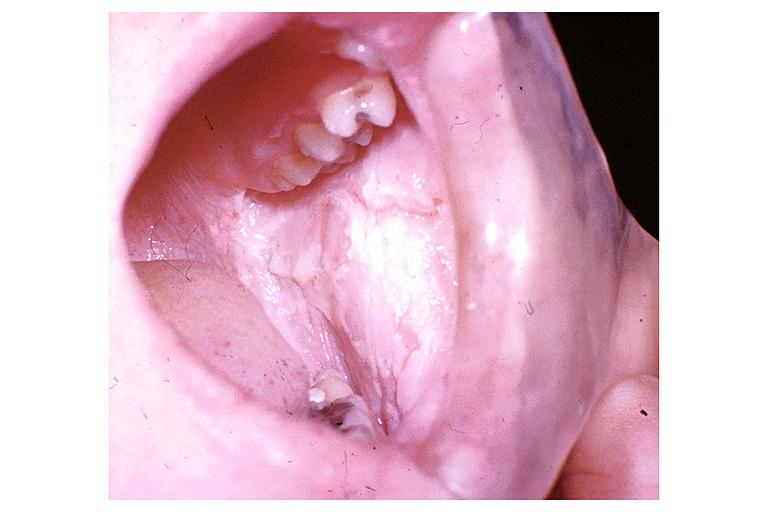s all the fat necrosis present?
Answer the question using a single word or phrase. No 